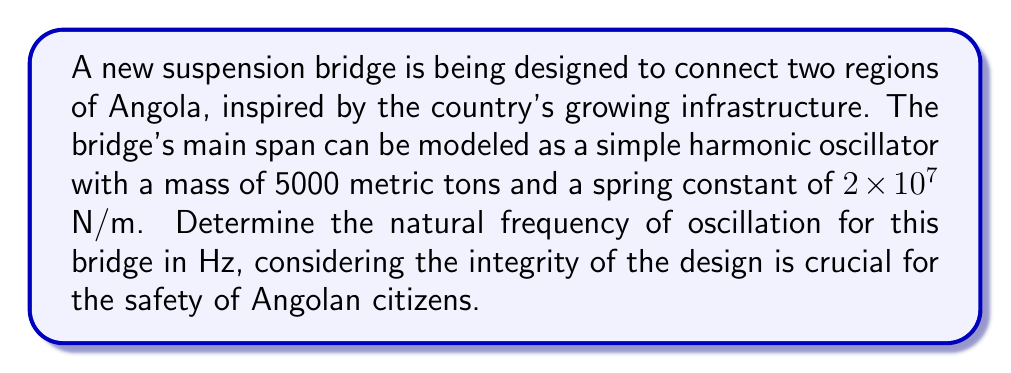Show me your answer to this math problem. To solve this problem, we'll use the equation for the natural frequency of a simple harmonic oscillator:

$$f = \frac{1}{2\pi} \sqrt{\frac{k}{m}}$$

Where:
$f$ = natural frequency (Hz)
$k$ = spring constant (N/m)
$m$ = mass (kg)

Given:
$k = 2 \times 10^7$ N/m
$m = 5000$ metric tons = $5 \times 10^6$ kg

Step 1: Substitute the values into the equation:

$$f = \frac{1}{2\pi} \sqrt{\frac{2 \times 10^7}{5 \times 10^6}}$$

Step 2: Simplify inside the square root:

$$f = \frac{1}{2\pi} \sqrt{4}$$

Step 3: Calculate the square root:

$$f = \frac{1}{2\pi} \times 2$$

Step 4: Simplify:

$$f = \frac{1}{\pi}$$

Step 5: Calculate the final value:

$$f \approx 0.3183 \text{ Hz}$$

This frequency represents the natural oscillation of the bridge, which is crucial for understanding its behavior under various loads and environmental conditions, ensuring the safety and integrity of the structure for Angolan citizens.
Answer: The natural frequency of oscillation for the suspension bridge is approximately 0.3183 Hz. 